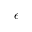<formula> <loc_0><loc_0><loc_500><loc_500>\epsilon</formula> 